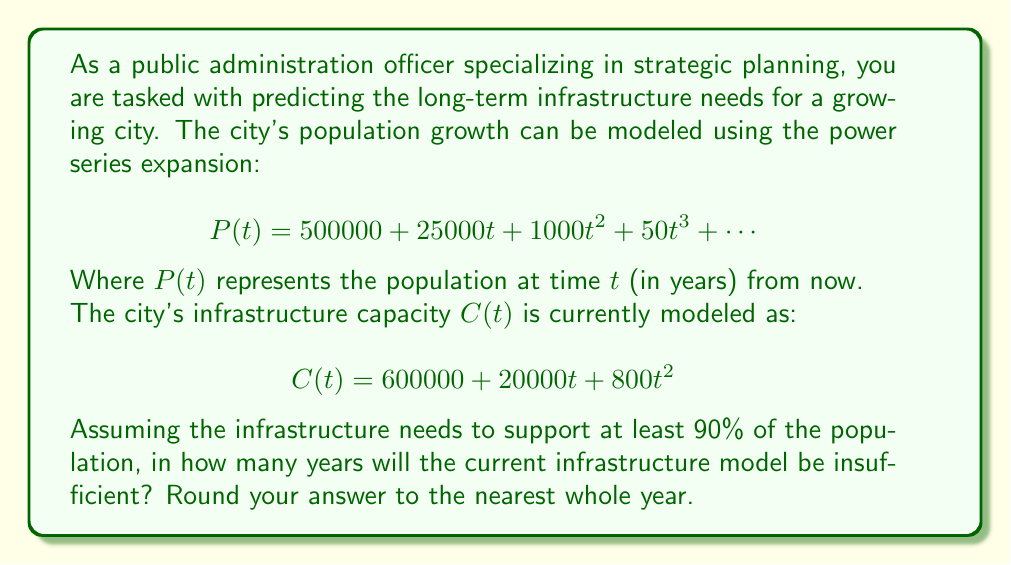Can you solve this math problem? To solve this problem, we need to follow these steps:

1) First, we need to determine when the infrastructure capacity will be less than 90% of the population. This can be expressed as:

   $$C(t) < 0.9P(t)$$

2) Substituting the given equations:

   $$600000 + 20000t + 800t^2 < 0.9(500000 + 25000t + 1000t^2 + 50t^3 + \cdots)$$

3) Let's simplify the right side of the inequality:

   $$600000 + 20000t + 800t^2 < 450000 + 22500t + 900t^2 + 45t^3 + \cdots$$

4) Subtracting the left side from both sides:

   $$0 < -150000 + 2500t + 100t^2 + 45t^3 + \cdots$$

5) This is a polynomial inequality. To solve it exactly, we would need to know all the terms of the series. However, we can approximate the solution by considering the first few terms.

6) Let's solve the cubic equation:

   $$-150000 + 2500t + 100t^2 + 45t^3 = 0$$

7) This equation can be solved numerically. Using a calculator or computer algebra system, we find that the positive real solution to this equation is approximately 10.76 years.

8) This means that after about 10.76 years, the infrastructure capacity will be less than 90% of the population according to our approximation.

9) Rounding to the nearest whole year, we get 11 years.

Note that this is an approximation, as we've ignored higher-order terms in the power series. In practice, you would want to use more terms for greater accuracy, or use computational methods to analyze the full series.
Answer: 11 years 